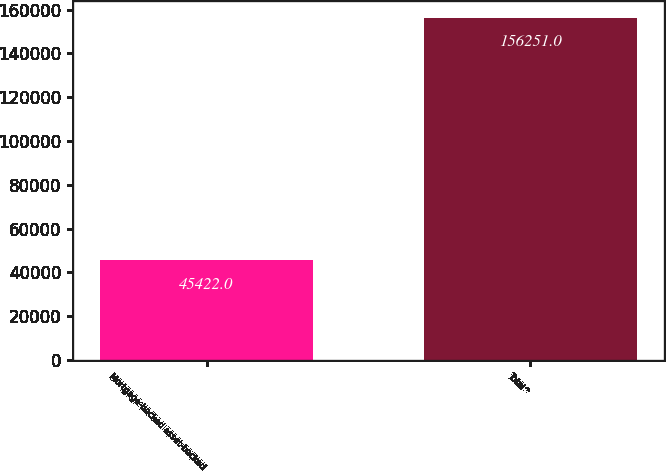Convert chart. <chart><loc_0><loc_0><loc_500><loc_500><bar_chart><fcel>Mortgage-backed asset-backed<fcel>Total^<nl><fcel>45422<fcel>156251<nl></chart> 